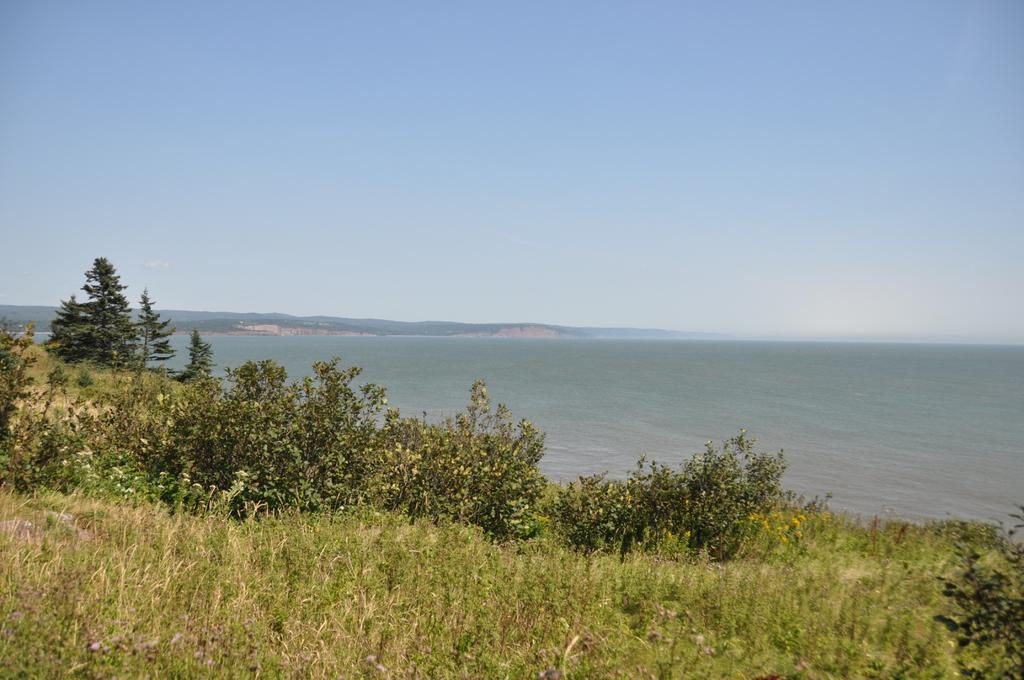What type of vegetation can be seen in the image? There are trees and plants in the image. What natural element is visible in the image? There is water visible in the image. How would you describe the sky in the image? The sky is blue and cloudy in the image. How many cherries are hanging from the trees in the image? There are no cherries visible in the image; it only features trees and plants. Is there an arch visible in the image? There is no arch present in the image. 